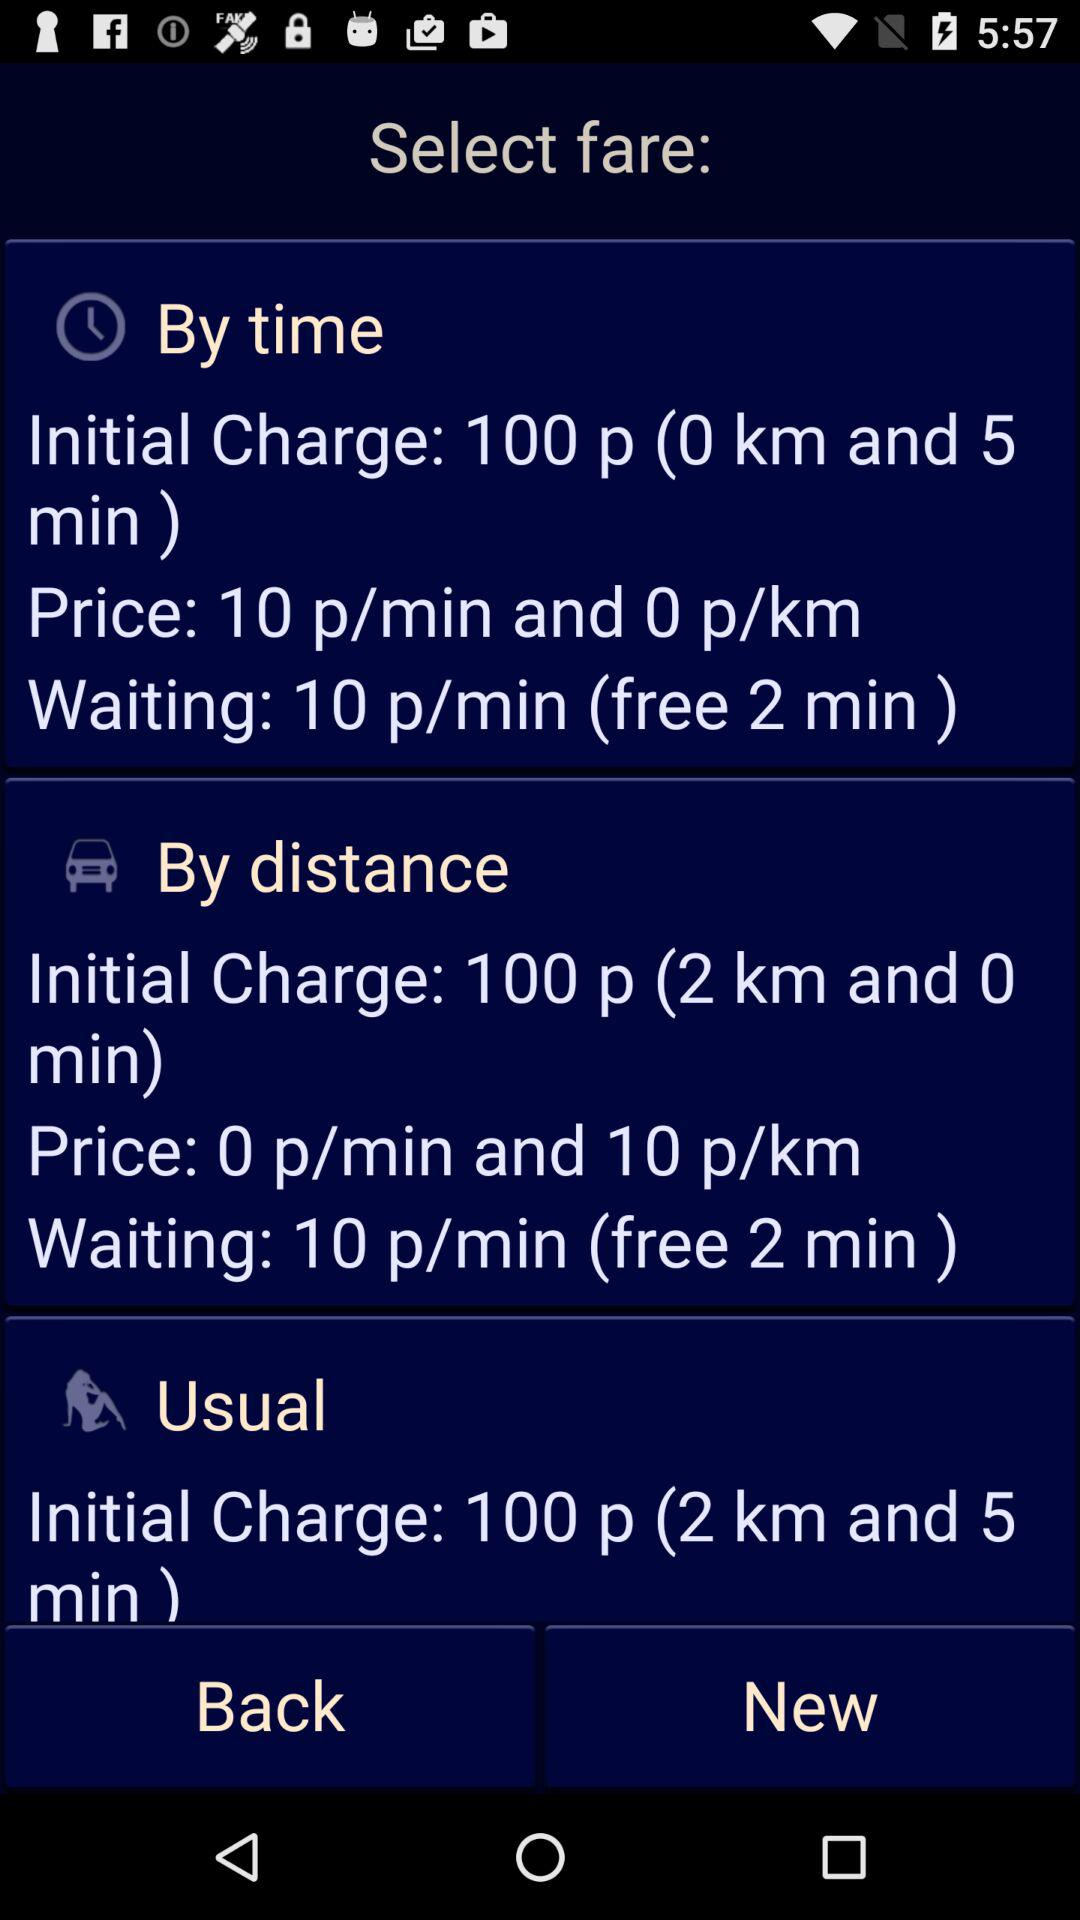How many fares are available?
Answer the question using a single word or phrase. 3 